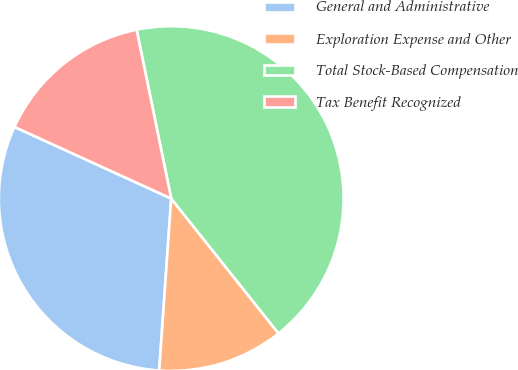Convert chart to OTSL. <chart><loc_0><loc_0><loc_500><loc_500><pie_chart><fcel>General and Administrative<fcel>Exploration Expense and Other<fcel>Total Stock-Based Compensation<fcel>Tax Benefit Recognized<nl><fcel>30.71%<fcel>11.81%<fcel>42.52%<fcel>14.96%<nl></chart> 